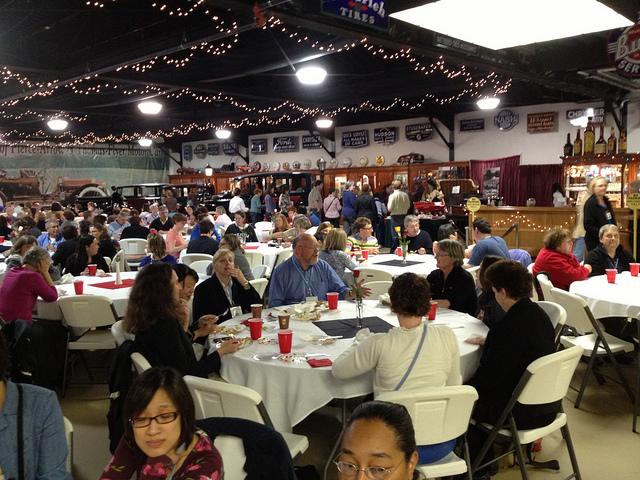Are there many people in the room?
Quick response, please. Yes. What color are the tablecloths?
Keep it brief. White. What is hanging from the ceiling?
Keep it brief. Lights. 